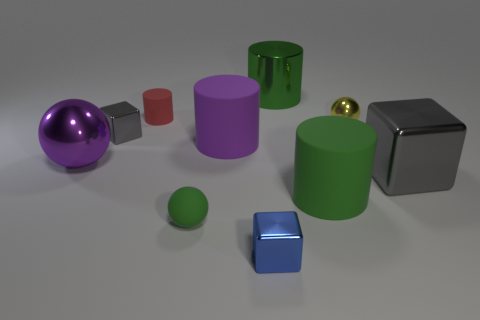Subtract all spheres. How many objects are left? 7 Add 2 purple shiny spheres. How many purple shiny spheres exist? 3 Subtract 2 green cylinders. How many objects are left? 8 Subtract all big objects. Subtract all rubber cylinders. How many objects are left? 2 Add 6 blue shiny objects. How many blue shiny objects are left? 7 